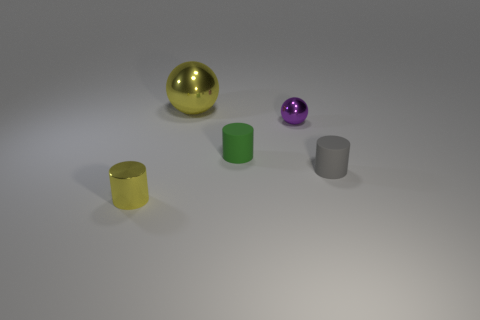Subtract all small metal cylinders. How many cylinders are left? 2 Subtract all cyan cylinders. How many yellow balls are left? 1 Add 2 red cylinders. How many objects exist? 7 Subtract all gray cylinders. How many cylinders are left? 2 Subtract 1 yellow balls. How many objects are left? 4 Subtract all spheres. How many objects are left? 3 Subtract 2 balls. How many balls are left? 0 Subtract all cyan cylinders. Subtract all green balls. How many cylinders are left? 3 Subtract all small gray objects. Subtract all green rubber cylinders. How many objects are left? 3 Add 1 small green cylinders. How many small green cylinders are left? 2 